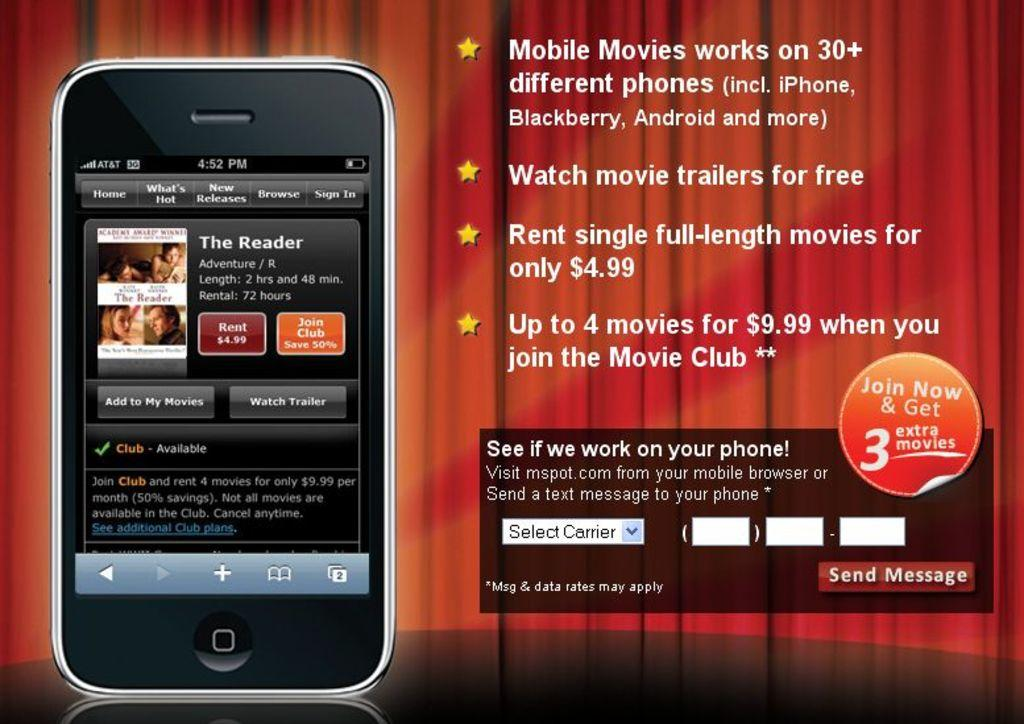<image>
Share a concise interpretation of the image provided. In front of a red curtain is a touch screen, cell phone with AT&T service and an advertisement for mobile movies next to it. 